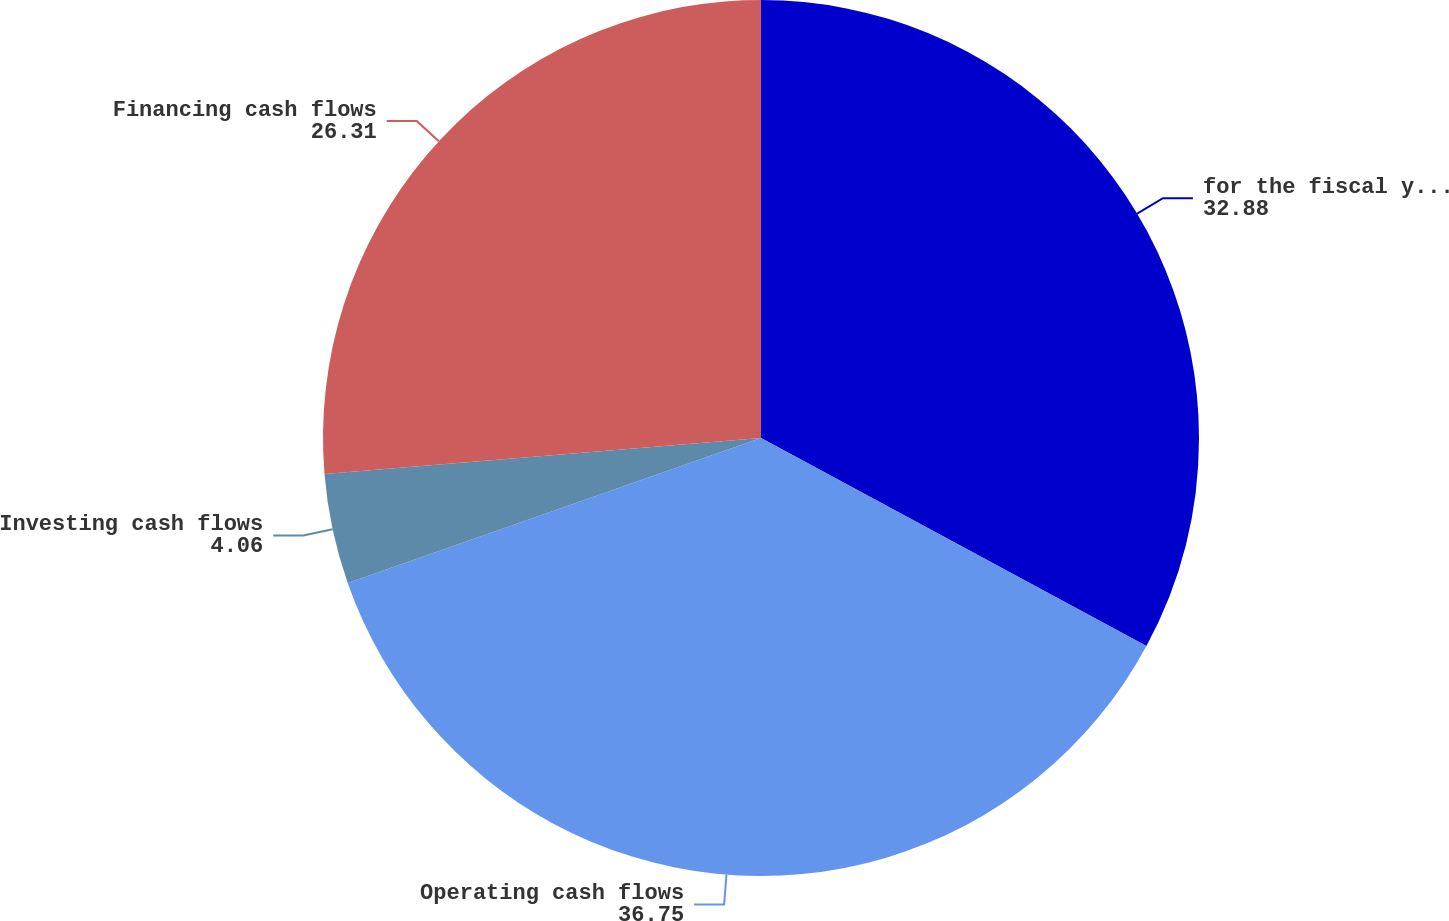<chart> <loc_0><loc_0><loc_500><loc_500><pie_chart><fcel>for the fiscal years ended<fcel>Operating cash flows<fcel>Investing cash flows<fcel>Financing cash flows<nl><fcel>32.88%<fcel>36.75%<fcel>4.06%<fcel>26.31%<nl></chart> 